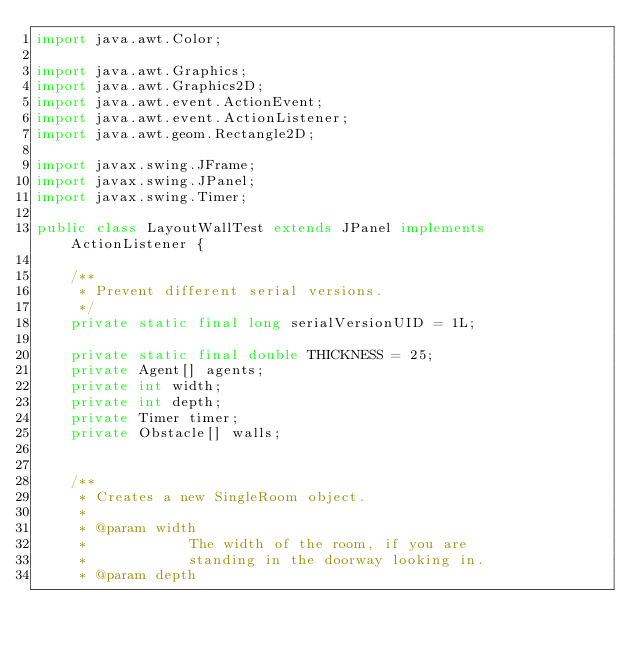Convert code to text. <code><loc_0><loc_0><loc_500><loc_500><_Java_>import java.awt.Color;

import java.awt.Graphics;
import java.awt.Graphics2D;
import java.awt.event.ActionEvent;
import java.awt.event.ActionListener;
import java.awt.geom.Rectangle2D;

import javax.swing.JFrame;
import javax.swing.JPanel;
import javax.swing.Timer;

public class LayoutWallTest extends JPanel implements ActionListener {

    /**
     * Prevent different serial versions.
     */
    private static final long serialVersionUID = 1L;

    private static final double THICKNESS = 25;
    private Agent[] agents;
    private int width;
    private int depth;
    private Timer timer;
    private Obstacle[] walls;


    /**
     * Creates a new SingleRoom object.
     * 
     * @param width
     *            The width of the room, if you are
     *            standing in the doorway looking in.
     * @param depth</code> 